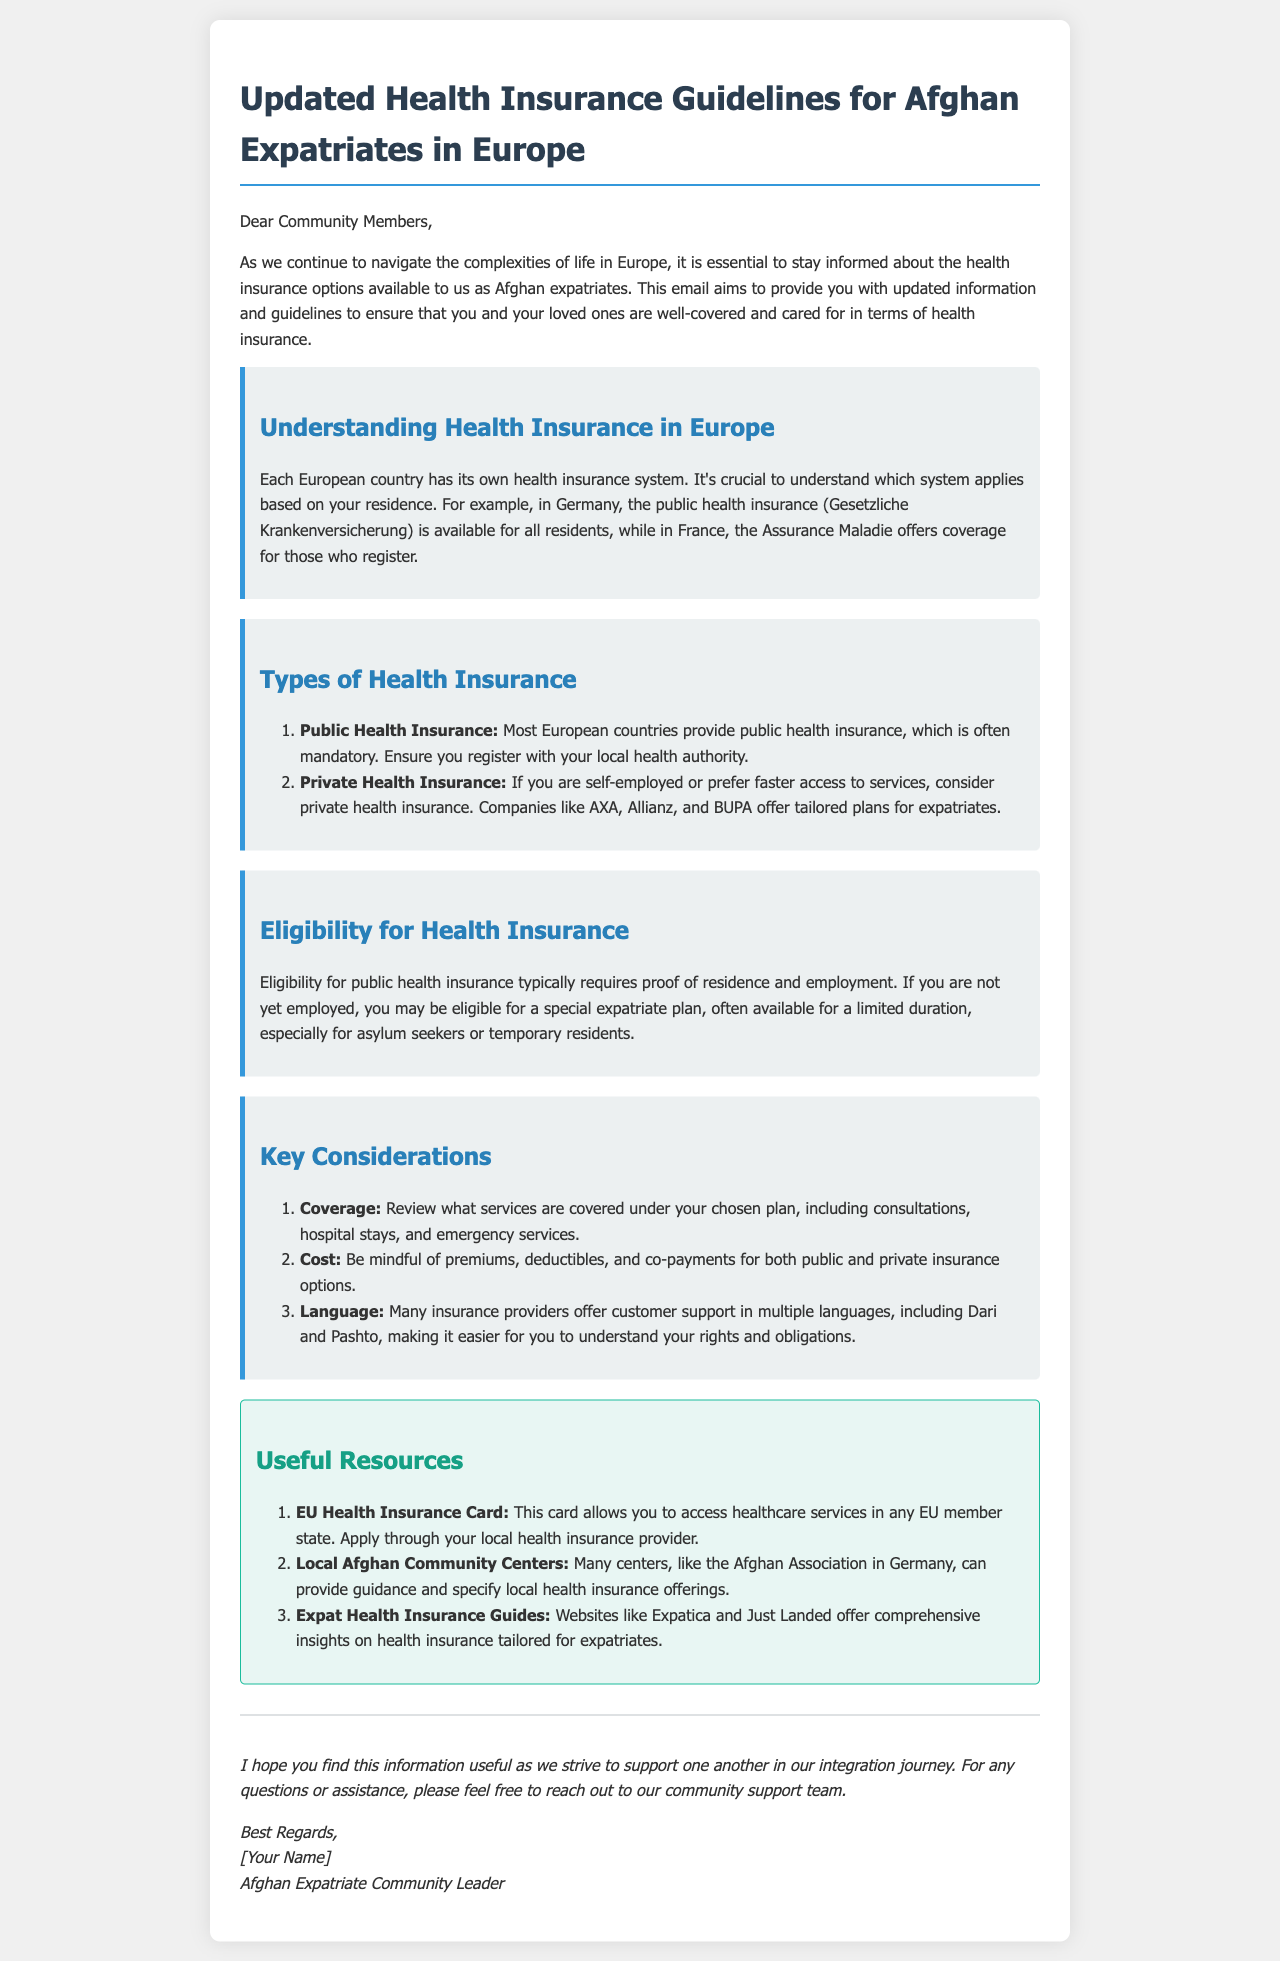What is the title of the document? The title is the main heading of the document that introduces the content, which is "Updated Health Insurance Guidelines for Afghan Expatriates in Europe."
Answer: Updated Health Insurance Guidelines for Afghan Expatriates in Europe What type of health insurance is often mandatory in most European countries? The document states that public health insurance is often mandatory.
Answer: Public Health Insurance Which health insurance provider offers tailored plans for expatriates? The document mentions several companies, one of which is AXA.
Answer: AXA What is required for eligibility for public health insurance? The document specifies that eligibility typically requires proof of residence and employment.
Answer: Proof of residence and employment Name one useful resource mentioned in the document for accessing healthcare services in the EU. The document lists the EU Health Insurance Card as a useful resource.
Answer: EU Health Insurance Card What do many insurance providers offer customer support in? The document notes that many insurance providers offer support in multiple languages, including Dari and Pashto.
Answer: Dari and Pashto What should be reviewed under a chosen health insurance plan? The document highlights that coverage, including services provided, should be reviewed.
Answer: Coverage Which community center is mentioned as a local resource for guidance on health insurance? The document refers to the Afghan Association in Germany as a local community center.
Answer: Afghan Association in Germany How can one apply for the EU Health Insurance Card? The document states that one can apply through their local health insurance provider.
Answer: Local health insurance provider 